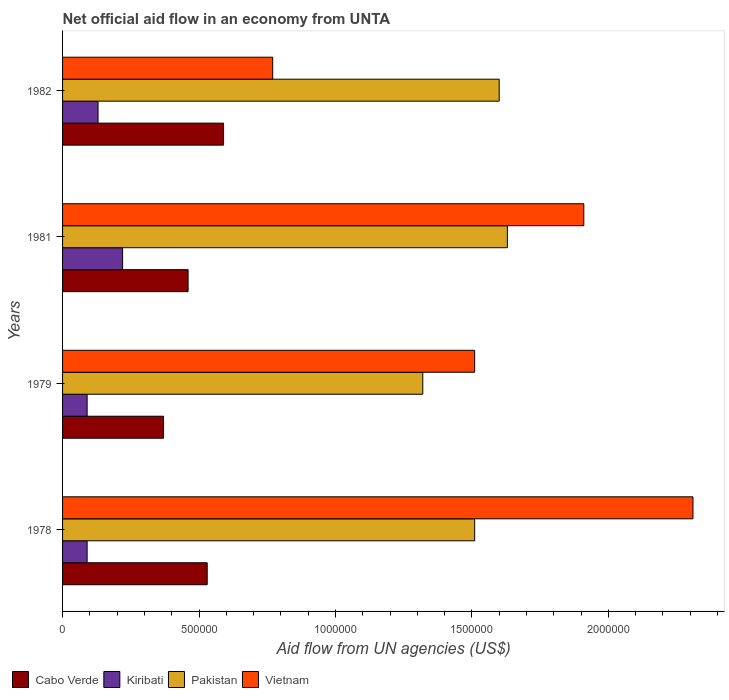How many groups of bars are there?
Make the answer very short. 4. How many bars are there on the 3rd tick from the top?
Provide a short and direct response. 4. How many bars are there on the 2nd tick from the bottom?
Offer a very short reply. 4. What is the label of the 4th group of bars from the top?
Your answer should be very brief. 1978. In how many cases, is the number of bars for a given year not equal to the number of legend labels?
Ensure brevity in your answer.  0. What is the net official aid flow in Kiribati in 1979?
Offer a very short reply. 9.00e+04. Across all years, what is the maximum net official aid flow in Vietnam?
Provide a short and direct response. 2.31e+06. Across all years, what is the minimum net official aid flow in Pakistan?
Provide a short and direct response. 1.32e+06. In which year was the net official aid flow in Kiribati maximum?
Give a very brief answer. 1981. In which year was the net official aid flow in Vietnam minimum?
Provide a succinct answer. 1982. What is the total net official aid flow in Pakistan in the graph?
Provide a short and direct response. 6.06e+06. What is the difference between the net official aid flow in Vietnam in 1981 and that in 1982?
Your response must be concise. 1.14e+06. What is the difference between the net official aid flow in Kiribati in 1979 and the net official aid flow in Pakistan in 1978?
Provide a succinct answer. -1.42e+06. What is the average net official aid flow in Kiribati per year?
Keep it short and to the point. 1.32e+05. In the year 1981, what is the difference between the net official aid flow in Vietnam and net official aid flow in Cabo Verde?
Your response must be concise. 1.45e+06. In how many years, is the net official aid flow in Cabo Verde greater than 1600000 US$?
Provide a short and direct response. 0. What is the ratio of the net official aid flow in Pakistan in 1979 to that in 1982?
Make the answer very short. 0.82. What is the difference between the highest and the second highest net official aid flow in Kiribati?
Offer a terse response. 9.00e+04. What is the difference between the highest and the lowest net official aid flow in Kiribati?
Give a very brief answer. 1.30e+05. In how many years, is the net official aid flow in Pakistan greater than the average net official aid flow in Pakistan taken over all years?
Offer a very short reply. 2. Is the sum of the net official aid flow in Pakistan in 1978 and 1979 greater than the maximum net official aid flow in Cabo Verde across all years?
Your answer should be compact. Yes. What does the 1st bar from the top in 1981 represents?
Your response must be concise. Vietnam. What does the 4th bar from the bottom in 1982 represents?
Your response must be concise. Vietnam. Are all the bars in the graph horizontal?
Your answer should be compact. Yes. Are the values on the major ticks of X-axis written in scientific E-notation?
Give a very brief answer. No. How many legend labels are there?
Your answer should be very brief. 4. What is the title of the graph?
Your response must be concise. Net official aid flow in an economy from UNTA. What is the label or title of the X-axis?
Offer a terse response. Aid flow from UN agencies (US$). What is the label or title of the Y-axis?
Give a very brief answer. Years. What is the Aid flow from UN agencies (US$) of Cabo Verde in 1978?
Keep it short and to the point. 5.30e+05. What is the Aid flow from UN agencies (US$) in Pakistan in 1978?
Provide a succinct answer. 1.51e+06. What is the Aid flow from UN agencies (US$) of Vietnam in 1978?
Offer a terse response. 2.31e+06. What is the Aid flow from UN agencies (US$) of Cabo Verde in 1979?
Make the answer very short. 3.70e+05. What is the Aid flow from UN agencies (US$) in Pakistan in 1979?
Ensure brevity in your answer.  1.32e+06. What is the Aid flow from UN agencies (US$) in Vietnam in 1979?
Your response must be concise. 1.51e+06. What is the Aid flow from UN agencies (US$) of Cabo Verde in 1981?
Provide a succinct answer. 4.60e+05. What is the Aid flow from UN agencies (US$) in Pakistan in 1981?
Provide a succinct answer. 1.63e+06. What is the Aid flow from UN agencies (US$) in Vietnam in 1981?
Your answer should be very brief. 1.91e+06. What is the Aid flow from UN agencies (US$) in Cabo Verde in 1982?
Ensure brevity in your answer.  5.90e+05. What is the Aid flow from UN agencies (US$) in Pakistan in 1982?
Your response must be concise. 1.60e+06. What is the Aid flow from UN agencies (US$) of Vietnam in 1982?
Ensure brevity in your answer.  7.70e+05. Across all years, what is the maximum Aid flow from UN agencies (US$) of Cabo Verde?
Offer a terse response. 5.90e+05. Across all years, what is the maximum Aid flow from UN agencies (US$) in Pakistan?
Provide a succinct answer. 1.63e+06. Across all years, what is the maximum Aid flow from UN agencies (US$) in Vietnam?
Provide a short and direct response. 2.31e+06. Across all years, what is the minimum Aid flow from UN agencies (US$) of Cabo Verde?
Make the answer very short. 3.70e+05. Across all years, what is the minimum Aid flow from UN agencies (US$) of Kiribati?
Make the answer very short. 9.00e+04. Across all years, what is the minimum Aid flow from UN agencies (US$) in Pakistan?
Give a very brief answer. 1.32e+06. Across all years, what is the minimum Aid flow from UN agencies (US$) of Vietnam?
Provide a short and direct response. 7.70e+05. What is the total Aid flow from UN agencies (US$) of Cabo Verde in the graph?
Offer a terse response. 1.95e+06. What is the total Aid flow from UN agencies (US$) in Kiribati in the graph?
Give a very brief answer. 5.30e+05. What is the total Aid flow from UN agencies (US$) of Pakistan in the graph?
Offer a very short reply. 6.06e+06. What is the total Aid flow from UN agencies (US$) of Vietnam in the graph?
Your answer should be very brief. 6.50e+06. What is the difference between the Aid flow from UN agencies (US$) in Kiribati in 1978 and that in 1979?
Give a very brief answer. 0. What is the difference between the Aid flow from UN agencies (US$) of Cabo Verde in 1978 and that in 1981?
Give a very brief answer. 7.00e+04. What is the difference between the Aid flow from UN agencies (US$) of Cabo Verde in 1978 and that in 1982?
Keep it short and to the point. -6.00e+04. What is the difference between the Aid flow from UN agencies (US$) of Vietnam in 1978 and that in 1982?
Give a very brief answer. 1.54e+06. What is the difference between the Aid flow from UN agencies (US$) of Kiribati in 1979 and that in 1981?
Make the answer very short. -1.30e+05. What is the difference between the Aid flow from UN agencies (US$) of Pakistan in 1979 and that in 1981?
Offer a very short reply. -3.10e+05. What is the difference between the Aid flow from UN agencies (US$) of Vietnam in 1979 and that in 1981?
Ensure brevity in your answer.  -4.00e+05. What is the difference between the Aid flow from UN agencies (US$) of Cabo Verde in 1979 and that in 1982?
Provide a short and direct response. -2.20e+05. What is the difference between the Aid flow from UN agencies (US$) in Pakistan in 1979 and that in 1982?
Your response must be concise. -2.80e+05. What is the difference between the Aid flow from UN agencies (US$) of Vietnam in 1979 and that in 1982?
Offer a very short reply. 7.40e+05. What is the difference between the Aid flow from UN agencies (US$) in Kiribati in 1981 and that in 1982?
Your response must be concise. 9.00e+04. What is the difference between the Aid flow from UN agencies (US$) in Pakistan in 1981 and that in 1982?
Your answer should be very brief. 3.00e+04. What is the difference between the Aid flow from UN agencies (US$) in Vietnam in 1981 and that in 1982?
Provide a short and direct response. 1.14e+06. What is the difference between the Aid flow from UN agencies (US$) of Cabo Verde in 1978 and the Aid flow from UN agencies (US$) of Kiribati in 1979?
Your response must be concise. 4.40e+05. What is the difference between the Aid flow from UN agencies (US$) in Cabo Verde in 1978 and the Aid flow from UN agencies (US$) in Pakistan in 1979?
Ensure brevity in your answer.  -7.90e+05. What is the difference between the Aid flow from UN agencies (US$) in Cabo Verde in 1978 and the Aid flow from UN agencies (US$) in Vietnam in 1979?
Give a very brief answer. -9.80e+05. What is the difference between the Aid flow from UN agencies (US$) in Kiribati in 1978 and the Aid flow from UN agencies (US$) in Pakistan in 1979?
Your answer should be compact. -1.23e+06. What is the difference between the Aid flow from UN agencies (US$) in Kiribati in 1978 and the Aid flow from UN agencies (US$) in Vietnam in 1979?
Make the answer very short. -1.42e+06. What is the difference between the Aid flow from UN agencies (US$) in Pakistan in 1978 and the Aid flow from UN agencies (US$) in Vietnam in 1979?
Offer a very short reply. 0. What is the difference between the Aid flow from UN agencies (US$) in Cabo Verde in 1978 and the Aid flow from UN agencies (US$) in Kiribati in 1981?
Ensure brevity in your answer.  3.10e+05. What is the difference between the Aid flow from UN agencies (US$) in Cabo Verde in 1978 and the Aid flow from UN agencies (US$) in Pakistan in 1981?
Offer a terse response. -1.10e+06. What is the difference between the Aid flow from UN agencies (US$) in Cabo Verde in 1978 and the Aid flow from UN agencies (US$) in Vietnam in 1981?
Your answer should be very brief. -1.38e+06. What is the difference between the Aid flow from UN agencies (US$) in Kiribati in 1978 and the Aid flow from UN agencies (US$) in Pakistan in 1981?
Offer a terse response. -1.54e+06. What is the difference between the Aid flow from UN agencies (US$) of Kiribati in 1978 and the Aid flow from UN agencies (US$) of Vietnam in 1981?
Offer a terse response. -1.82e+06. What is the difference between the Aid flow from UN agencies (US$) in Pakistan in 1978 and the Aid flow from UN agencies (US$) in Vietnam in 1981?
Give a very brief answer. -4.00e+05. What is the difference between the Aid flow from UN agencies (US$) in Cabo Verde in 1978 and the Aid flow from UN agencies (US$) in Pakistan in 1982?
Provide a succinct answer. -1.07e+06. What is the difference between the Aid flow from UN agencies (US$) in Kiribati in 1978 and the Aid flow from UN agencies (US$) in Pakistan in 1982?
Ensure brevity in your answer.  -1.51e+06. What is the difference between the Aid flow from UN agencies (US$) in Kiribati in 1978 and the Aid flow from UN agencies (US$) in Vietnam in 1982?
Your response must be concise. -6.80e+05. What is the difference between the Aid flow from UN agencies (US$) in Pakistan in 1978 and the Aid flow from UN agencies (US$) in Vietnam in 1982?
Offer a very short reply. 7.40e+05. What is the difference between the Aid flow from UN agencies (US$) of Cabo Verde in 1979 and the Aid flow from UN agencies (US$) of Pakistan in 1981?
Your answer should be compact. -1.26e+06. What is the difference between the Aid flow from UN agencies (US$) of Cabo Verde in 1979 and the Aid flow from UN agencies (US$) of Vietnam in 1981?
Your answer should be very brief. -1.54e+06. What is the difference between the Aid flow from UN agencies (US$) in Kiribati in 1979 and the Aid flow from UN agencies (US$) in Pakistan in 1981?
Offer a very short reply. -1.54e+06. What is the difference between the Aid flow from UN agencies (US$) of Kiribati in 1979 and the Aid flow from UN agencies (US$) of Vietnam in 1981?
Your answer should be very brief. -1.82e+06. What is the difference between the Aid flow from UN agencies (US$) in Pakistan in 1979 and the Aid flow from UN agencies (US$) in Vietnam in 1981?
Keep it short and to the point. -5.90e+05. What is the difference between the Aid flow from UN agencies (US$) of Cabo Verde in 1979 and the Aid flow from UN agencies (US$) of Kiribati in 1982?
Your response must be concise. 2.40e+05. What is the difference between the Aid flow from UN agencies (US$) of Cabo Verde in 1979 and the Aid flow from UN agencies (US$) of Pakistan in 1982?
Offer a terse response. -1.23e+06. What is the difference between the Aid flow from UN agencies (US$) in Cabo Verde in 1979 and the Aid flow from UN agencies (US$) in Vietnam in 1982?
Keep it short and to the point. -4.00e+05. What is the difference between the Aid flow from UN agencies (US$) in Kiribati in 1979 and the Aid flow from UN agencies (US$) in Pakistan in 1982?
Give a very brief answer. -1.51e+06. What is the difference between the Aid flow from UN agencies (US$) in Kiribati in 1979 and the Aid flow from UN agencies (US$) in Vietnam in 1982?
Your answer should be compact. -6.80e+05. What is the difference between the Aid flow from UN agencies (US$) in Cabo Verde in 1981 and the Aid flow from UN agencies (US$) in Pakistan in 1982?
Your answer should be compact. -1.14e+06. What is the difference between the Aid flow from UN agencies (US$) in Cabo Verde in 1981 and the Aid flow from UN agencies (US$) in Vietnam in 1982?
Make the answer very short. -3.10e+05. What is the difference between the Aid flow from UN agencies (US$) in Kiribati in 1981 and the Aid flow from UN agencies (US$) in Pakistan in 1982?
Provide a short and direct response. -1.38e+06. What is the difference between the Aid flow from UN agencies (US$) in Kiribati in 1981 and the Aid flow from UN agencies (US$) in Vietnam in 1982?
Your answer should be compact. -5.50e+05. What is the difference between the Aid flow from UN agencies (US$) in Pakistan in 1981 and the Aid flow from UN agencies (US$) in Vietnam in 1982?
Your answer should be compact. 8.60e+05. What is the average Aid flow from UN agencies (US$) of Cabo Verde per year?
Offer a terse response. 4.88e+05. What is the average Aid flow from UN agencies (US$) of Kiribati per year?
Your response must be concise. 1.32e+05. What is the average Aid flow from UN agencies (US$) of Pakistan per year?
Make the answer very short. 1.52e+06. What is the average Aid flow from UN agencies (US$) in Vietnam per year?
Your answer should be compact. 1.62e+06. In the year 1978, what is the difference between the Aid flow from UN agencies (US$) in Cabo Verde and Aid flow from UN agencies (US$) in Kiribati?
Offer a terse response. 4.40e+05. In the year 1978, what is the difference between the Aid flow from UN agencies (US$) of Cabo Verde and Aid flow from UN agencies (US$) of Pakistan?
Provide a succinct answer. -9.80e+05. In the year 1978, what is the difference between the Aid flow from UN agencies (US$) in Cabo Verde and Aid flow from UN agencies (US$) in Vietnam?
Your answer should be very brief. -1.78e+06. In the year 1978, what is the difference between the Aid flow from UN agencies (US$) of Kiribati and Aid flow from UN agencies (US$) of Pakistan?
Provide a succinct answer. -1.42e+06. In the year 1978, what is the difference between the Aid flow from UN agencies (US$) of Kiribati and Aid flow from UN agencies (US$) of Vietnam?
Give a very brief answer. -2.22e+06. In the year 1978, what is the difference between the Aid flow from UN agencies (US$) in Pakistan and Aid flow from UN agencies (US$) in Vietnam?
Ensure brevity in your answer.  -8.00e+05. In the year 1979, what is the difference between the Aid flow from UN agencies (US$) in Cabo Verde and Aid flow from UN agencies (US$) in Kiribati?
Offer a very short reply. 2.80e+05. In the year 1979, what is the difference between the Aid flow from UN agencies (US$) of Cabo Verde and Aid flow from UN agencies (US$) of Pakistan?
Offer a terse response. -9.50e+05. In the year 1979, what is the difference between the Aid flow from UN agencies (US$) of Cabo Verde and Aid flow from UN agencies (US$) of Vietnam?
Your answer should be very brief. -1.14e+06. In the year 1979, what is the difference between the Aid flow from UN agencies (US$) in Kiribati and Aid flow from UN agencies (US$) in Pakistan?
Make the answer very short. -1.23e+06. In the year 1979, what is the difference between the Aid flow from UN agencies (US$) of Kiribati and Aid flow from UN agencies (US$) of Vietnam?
Your answer should be very brief. -1.42e+06. In the year 1981, what is the difference between the Aid flow from UN agencies (US$) in Cabo Verde and Aid flow from UN agencies (US$) in Pakistan?
Ensure brevity in your answer.  -1.17e+06. In the year 1981, what is the difference between the Aid flow from UN agencies (US$) in Cabo Verde and Aid flow from UN agencies (US$) in Vietnam?
Offer a very short reply. -1.45e+06. In the year 1981, what is the difference between the Aid flow from UN agencies (US$) of Kiribati and Aid flow from UN agencies (US$) of Pakistan?
Ensure brevity in your answer.  -1.41e+06. In the year 1981, what is the difference between the Aid flow from UN agencies (US$) in Kiribati and Aid flow from UN agencies (US$) in Vietnam?
Give a very brief answer. -1.69e+06. In the year 1981, what is the difference between the Aid flow from UN agencies (US$) in Pakistan and Aid flow from UN agencies (US$) in Vietnam?
Provide a short and direct response. -2.80e+05. In the year 1982, what is the difference between the Aid flow from UN agencies (US$) in Cabo Verde and Aid flow from UN agencies (US$) in Pakistan?
Your response must be concise. -1.01e+06. In the year 1982, what is the difference between the Aid flow from UN agencies (US$) in Cabo Verde and Aid flow from UN agencies (US$) in Vietnam?
Give a very brief answer. -1.80e+05. In the year 1982, what is the difference between the Aid flow from UN agencies (US$) in Kiribati and Aid flow from UN agencies (US$) in Pakistan?
Give a very brief answer. -1.47e+06. In the year 1982, what is the difference between the Aid flow from UN agencies (US$) in Kiribati and Aid flow from UN agencies (US$) in Vietnam?
Ensure brevity in your answer.  -6.40e+05. In the year 1982, what is the difference between the Aid flow from UN agencies (US$) in Pakistan and Aid flow from UN agencies (US$) in Vietnam?
Give a very brief answer. 8.30e+05. What is the ratio of the Aid flow from UN agencies (US$) of Cabo Verde in 1978 to that in 1979?
Keep it short and to the point. 1.43. What is the ratio of the Aid flow from UN agencies (US$) of Kiribati in 1978 to that in 1979?
Your response must be concise. 1. What is the ratio of the Aid flow from UN agencies (US$) in Pakistan in 1978 to that in 1979?
Ensure brevity in your answer.  1.14. What is the ratio of the Aid flow from UN agencies (US$) in Vietnam in 1978 to that in 1979?
Your answer should be compact. 1.53. What is the ratio of the Aid flow from UN agencies (US$) of Cabo Verde in 1978 to that in 1981?
Provide a short and direct response. 1.15. What is the ratio of the Aid flow from UN agencies (US$) in Kiribati in 1978 to that in 1981?
Your response must be concise. 0.41. What is the ratio of the Aid flow from UN agencies (US$) in Pakistan in 1978 to that in 1981?
Give a very brief answer. 0.93. What is the ratio of the Aid flow from UN agencies (US$) in Vietnam in 1978 to that in 1981?
Your answer should be very brief. 1.21. What is the ratio of the Aid flow from UN agencies (US$) in Cabo Verde in 1978 to that in 1982?
Provide a succinct answer. 0.9. What is the ratio of the Aid flow from UN agencies (US$) in Kiribati in 1978 to that in 1982?
Ensure brevity in your answer.  0.69. What is the ratio of the Aid flow from UN agencies (US$) in Pakistan in 1978 to that in 1982?
Provide a short and direct response. 0.94. What is the ratio of the Aid flow from UN agencies (US$) in Cabo Verde in 1979 to that in 1981?
Keep it short and to the point. 0.8. What is the ratio of the Aid flow from UN agencies (US$) of Kiribati in 1979 to that in 1981?
Ensure brevity in your answer.  0.41. What is the ratio of the Aid flow from UN agencies (US$) of Pakistan in 1979 to that in 1981?
Provide a short and direct response. 0.81. What is the ratio of the Aid flow from UN agencies (US$) in Vietnam in 1979 to that in 1981?
Give a very brief answer. 0.79. What is the ratio of the Aid flow from UN agencies (US$) in Cabo Verde in 1979 to that in 1982?
Offer a very short reply. 0.63. What is the ratio of the Aid flow from UN agencies (US$) of Kiribati in 1979 to that in 1982?
Give a very brief answer. 0.69. What is the ratio of the Aid flow from UN agencies (US$) of Pakistan in 1979 to that in 1982?
Keep it short and to the point. 0.82. What is the ratio of the Aid flow from UN agencies (US$) in Vietnam in 1979 to that in 1982?
Your response must be concise. 1.96. What is the ratio of the Aid flow from UN agencies (US$) of Cabo Verde in 1981 to that in 1982?
Your answer should be very brief. 0.78. What is the ratio of the Aid flow from UN agencies (US$) in Kiribati in 1981 to that in 1982?
Your response must be concise. 1.69. What is the ratio of the Aid flow from UN agencies (US$) of Pakistan in 1981 to that in 1982?
Ensure brevity in your answer.  1.02. What is the ratio of the Aid flow from UN agencies (US$) of Vietnam in 1981 to that in 1982?
Offer a terse response. 2.48. What is the difference between the highest and the second highest Aid flow from UN agencies (US$) in Pakistan?
Keep it short and to the point. 3.00e+04. What is the difference between the highest and the second highest Aid flow from UN agencies (US$) in Vietnam?
Your answer should be very brief. 4.00e+05. What is the difference between the highest and the lowest Aid flow from UN agencies (US$) in Kiribati?
Make the answer very short. 1.30e+05. What is the difference between the highest and the lowest Aid flow from UN agencies (US$) in Pakistan?
Ensure brevity in your answer.  3.10e+05. What is the difference between the highest and the lowest Aid flow from UN agencies (US$) in Vietnam?
Keep it short and to the point. 1.54e+06. 